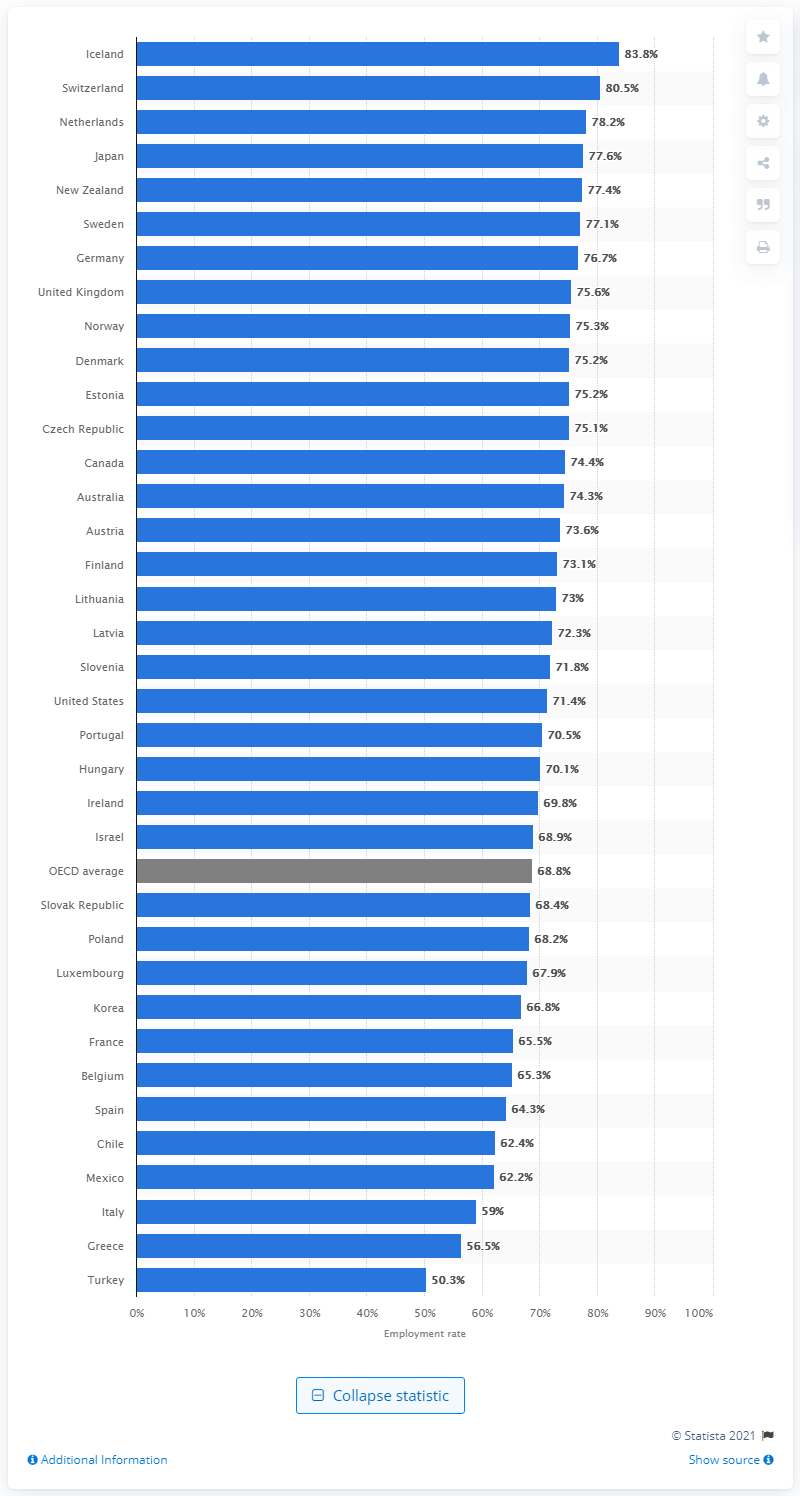Specify some key components in this picture. The employment rate of Iceland in 2019 was 83.8%. 